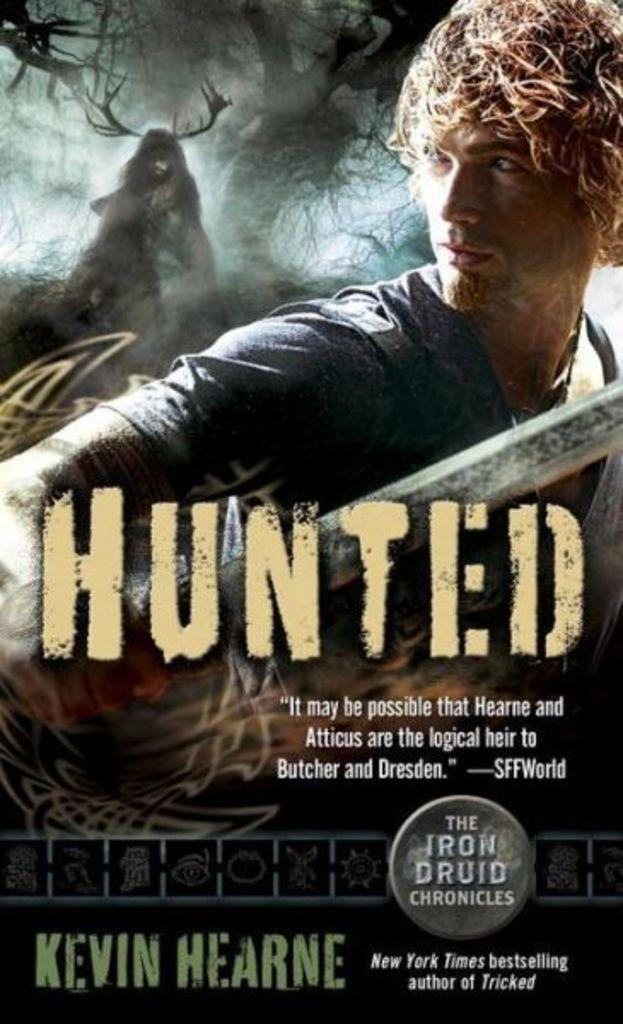What is featured in the image? There is a poster in the image. What is the main subject of the poster? The poster depicts a man holding a sword. Are there any words on the poster? Yes, there is text on the poster. What type of drug is the man holding in the image? The man is not holding a drug in the image; he is holding a sword. 